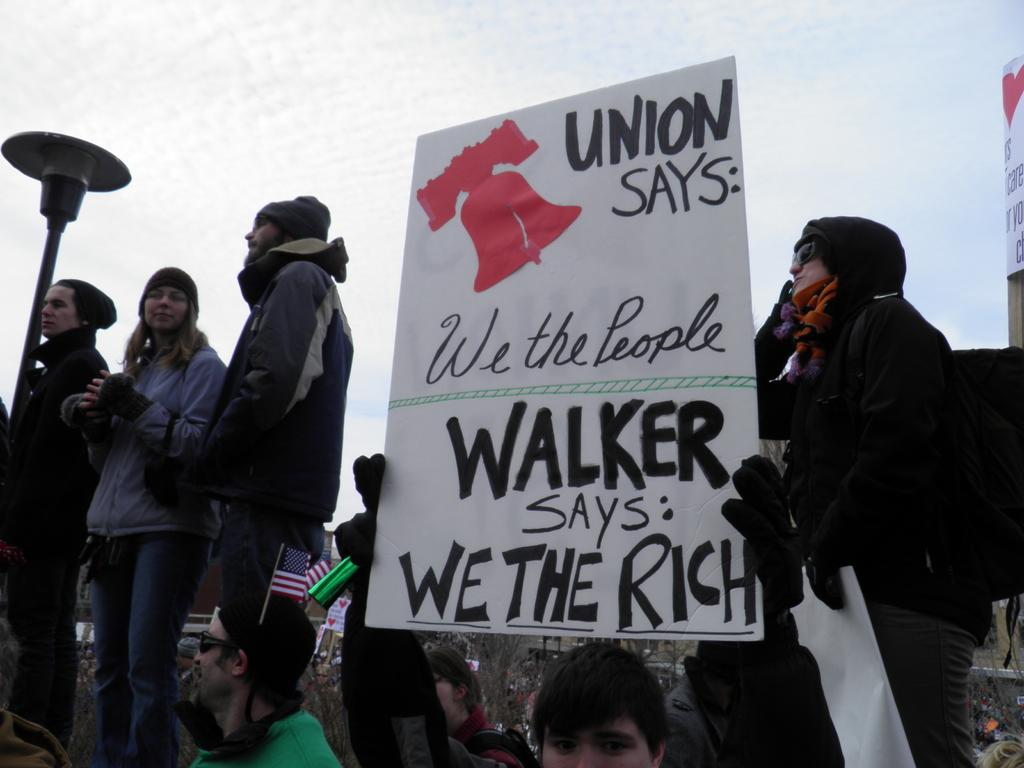How many people are in the image? There is a group of people in the image. What is the man holding in the image? The man is holding a board with text in the image. What type of lighting is visible in the image? There is a street lamp visible in the image. What can be seen in the sky in the image? The sky is visible in the image, and it appears to be cloudy. What type of toy is the man requesting in the image? There is no toy present in the image, nor is there any indication that the man is requesting anything. 